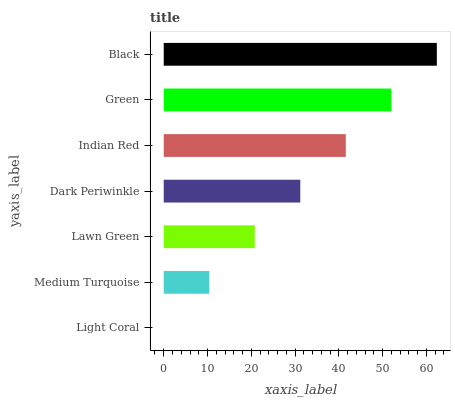Is Light Coral the minimum?
Answer yes or no. Yes. Is Black the maximum?
Answer yes or no. Yes. Is Medium Turquoise the minimum?
Answer yes or no. No. Is Medium Turquoise the maximum?
Answer yes or no. No. Is Medium Turquoise greater than Light Coral?
Answer yes or no. Yes. Is Light Coral less than Medium Turquoise?
Answer yes or no. Yes. Is Light Coral greater than Medium Turquoise?
Answer yes or no. No. Is Medium Turquoise less than Light Coral?
Answer yes or no. No. Is Dark Periwinkle the high median?
Answer yes or no. Yes. Is Dark Periwinkle the low median?
Answer yes or no. Yes. Is Medium Turquoise the high median?
Answer yes or no. No. Is Medium Turquoise the low median?
Answer yes or no. No. 